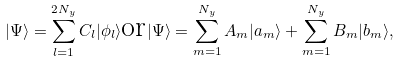Convert formula to latex. <formula><loc_0><loc_0><loc_500><loc_500>| \Psi \rangle = \sum _ { l = 1 } ^ { 2 N _ { y } } C _ { l } | \phi _ { l } \rangle \text {or} | \Psi \rangle = \sum _ { m = 1 } ^ { N _ { y } } A _ { m } | a _ { m } \rangle + \sum _ { m = 1 } ^ { N _ { y } } B _ { m } | b _ { m } \rangle ,</formula> 